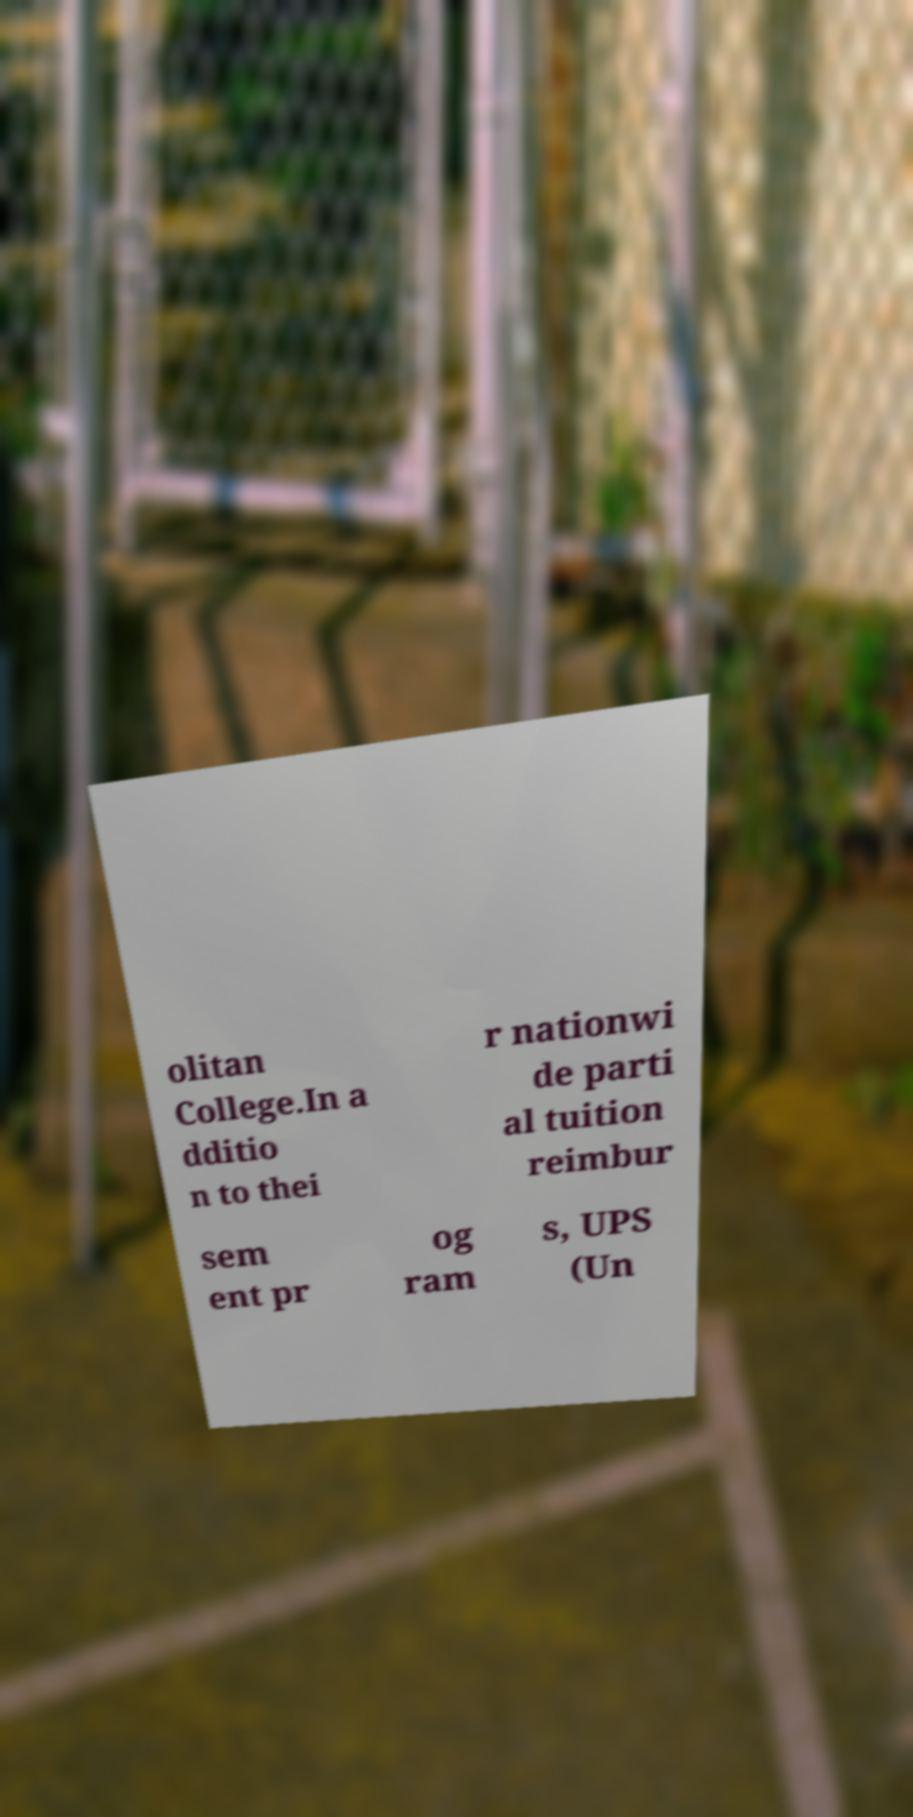Can you accurately transcribe the text from the provided image for me? olitan College.In a dditio n to thei r nationwi de parti al tuition reimbur sem ent pr og ram s, UPS (Un 